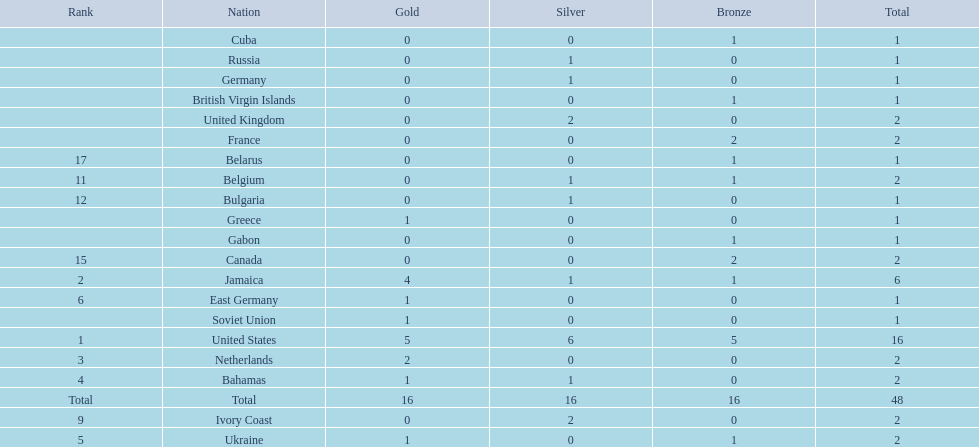After the united states, what country won the most gold medals. Jamaica. Can you give me this table as a dict? {'header': ['Rank', 'Nation', 'Gold', 'Silver', 'Bronze', 'Total'], 'rows': [['', 'Cuba', '0', '0', '1', '1'], ['', 'Russia', '0', '1', '0', '1'], ['', 'Germany', '0', '1', '0', '1'], ['', 'British Virgin Islands', '0', '0', '1', '1'], ['', 'United Kingdom', '0', '2', '0', '2'], ['', 'France', '0', '0', '2', '2'], ['17', 'Belarus', '0', '0', '1', '1'], ['11', 'Belgium', '0', '1', '1', '2'], ['12', 'Bulgaria', '0', '1', '0', '1'], ['', 'Greece', '1', '0', '0', '1'], ['', 'Gabon', '0', '0', '1', '1'], ['15', 'Canada', '0', '0', '2', '2'], ['2', 'Jamaica', '4', '1', '1', '6'], ['6', 'East Germany', '1', '0', '0', '1'], ['', 'Soviet Union', '1', '0', '0', '1'], ['1', 'United States', '5', '6', '5', '16'], ['3', 'Netherlands', '2', '0', '0', '2'], ['4', 'Bahamas', '1', '1', '0', '2'], ['Total', 'Total', '16', '16', '16', '48'], ['9', 'Ivory Coast', '0', '2', '0', '2'], ['5', 'Ukraine', '1', '0', '1', '2']]} 